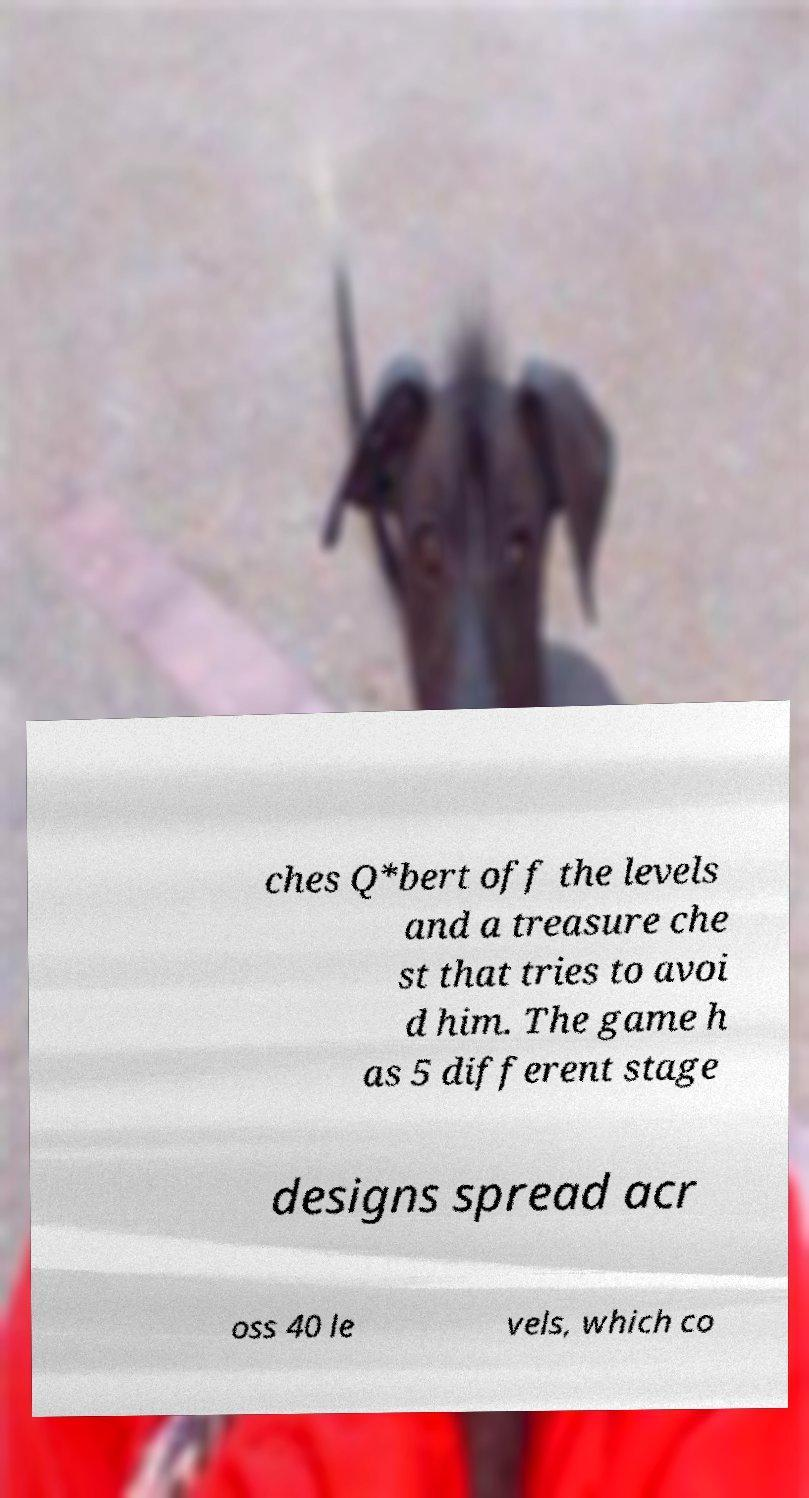Please read and relay the text visible in this image. What does it say? ches Q*bert off the levels and a treasure che st that tries to avoi d him. The game h as 5 different stage designs spread acr oss 40 le vels, which co 